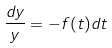Convert formula to latex. <formula><loc_0><loc_0><loc_500><loc_500>\frac { d y } { y } = - f ( t ) d t</formula> 